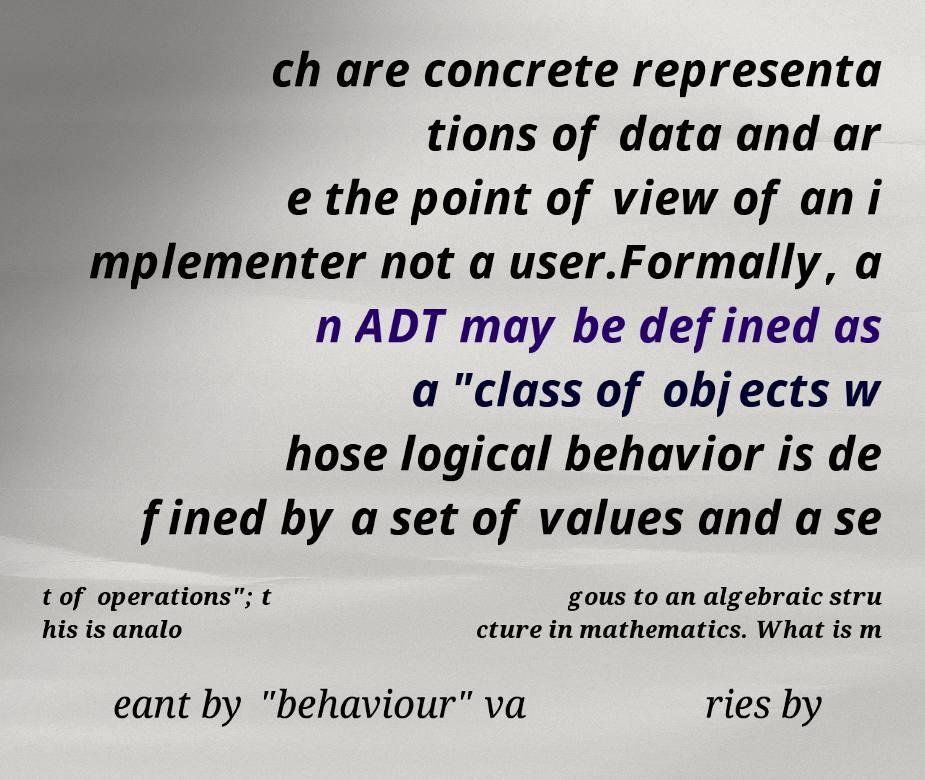Please read and relay the text visible in this image. What does it say? ch are concrete representa tions of data and ar e the point of view of an i mplementer not a user.Formally, a n ADT may be defined as a "class of objects w hose logical behavior is de fined by a set of values and a se t of operations"; t his is analo gous to an algebraic stru cture in mathematics. What is m eant by "behaviour" va ries by 